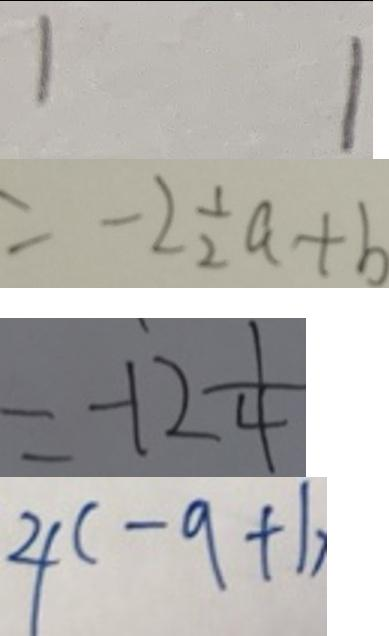Convert formula to latex. <formula><loc_0><loc_0><loc_500><loc_500>1 1 
 = - 2 \frac { 1 } { 2 } a + b 
 = - 1 2 \frac { 1 } { 4 } 
 4 ( - 9 + 1 )</formula> 